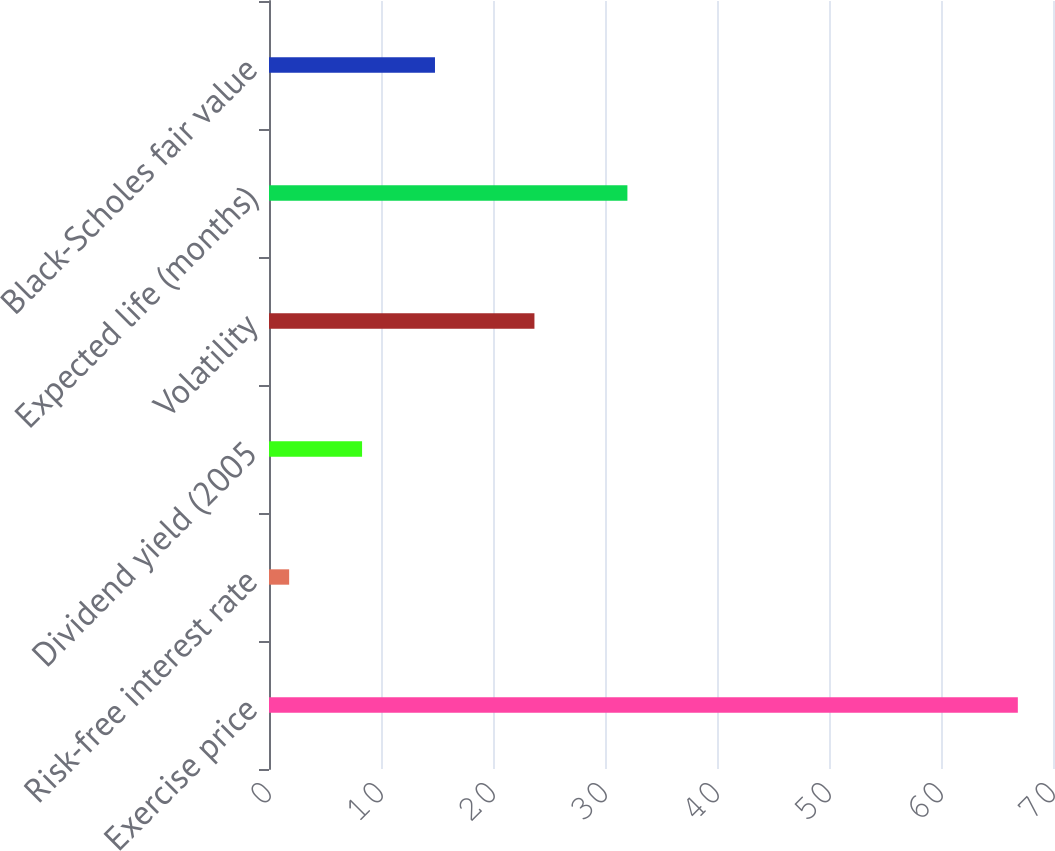<chart> <loc_0><loc_0><loc_500><loc_500><bar_chart><fcel>Exercise price<fcel>Risk-free interest rate<fcel>Dividend yield (2005<fcel>Volatility<fcel>Expected life (months)<fcel>Black-Scholes fair value<nl><fcel>66.86<fcel>1.8<fcel>8.31<fcel>23.7<fcel>32<fcel>14.82<nl></chart> 